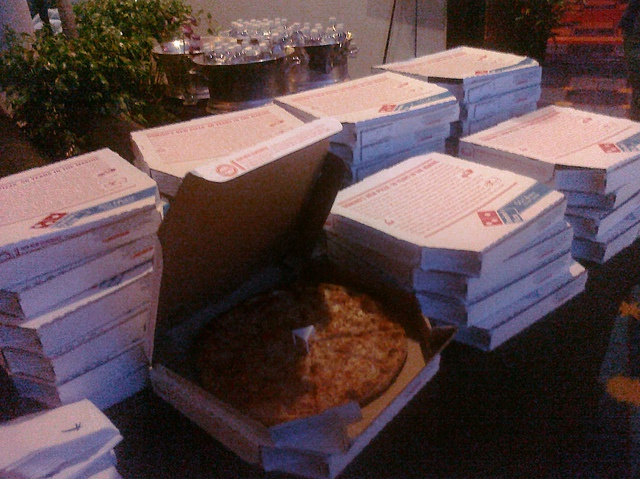Describe the objects in this image and their specific colors. I can see book in purple, black, and gray tones, pizza in purple, black, maroon, and brown tones, book in purple and pink tones, book in purple, black, maroon, and pink tones, and book in purple, lightpink, gray, and darkgray tones in this image. 